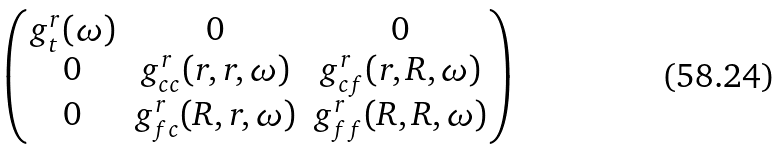<formula> <loc_0><loc_0><loc_500><loc_500>\begin{pmatrix} g ^ { r } _ { t } ( \omega ) & 0 & 0 \\ 0 & g ^ { r } _ { c c } ( { r } , { r } , \omega ) & g ^ { r } _ { c f } ( { r } , { R } , \omega ) \\ 0 & g ^ { r } _ { f c } ( { R } , { r } , \omega ) & g ^ { r } _ { f f } ( { R } , { R } , \omega ) \end{pmatrix}</formula> 